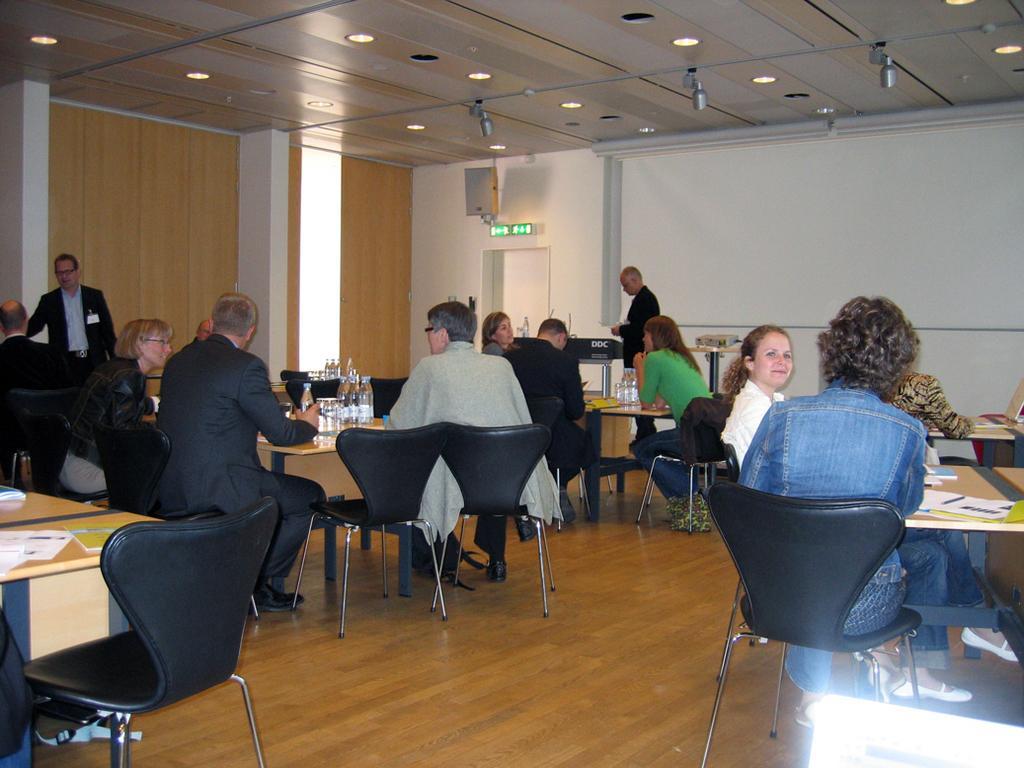Could you give a brief overview of what you see in this image? In this picture there are are of group of people sitting and they have a table in front of them with some papers and water bottles 